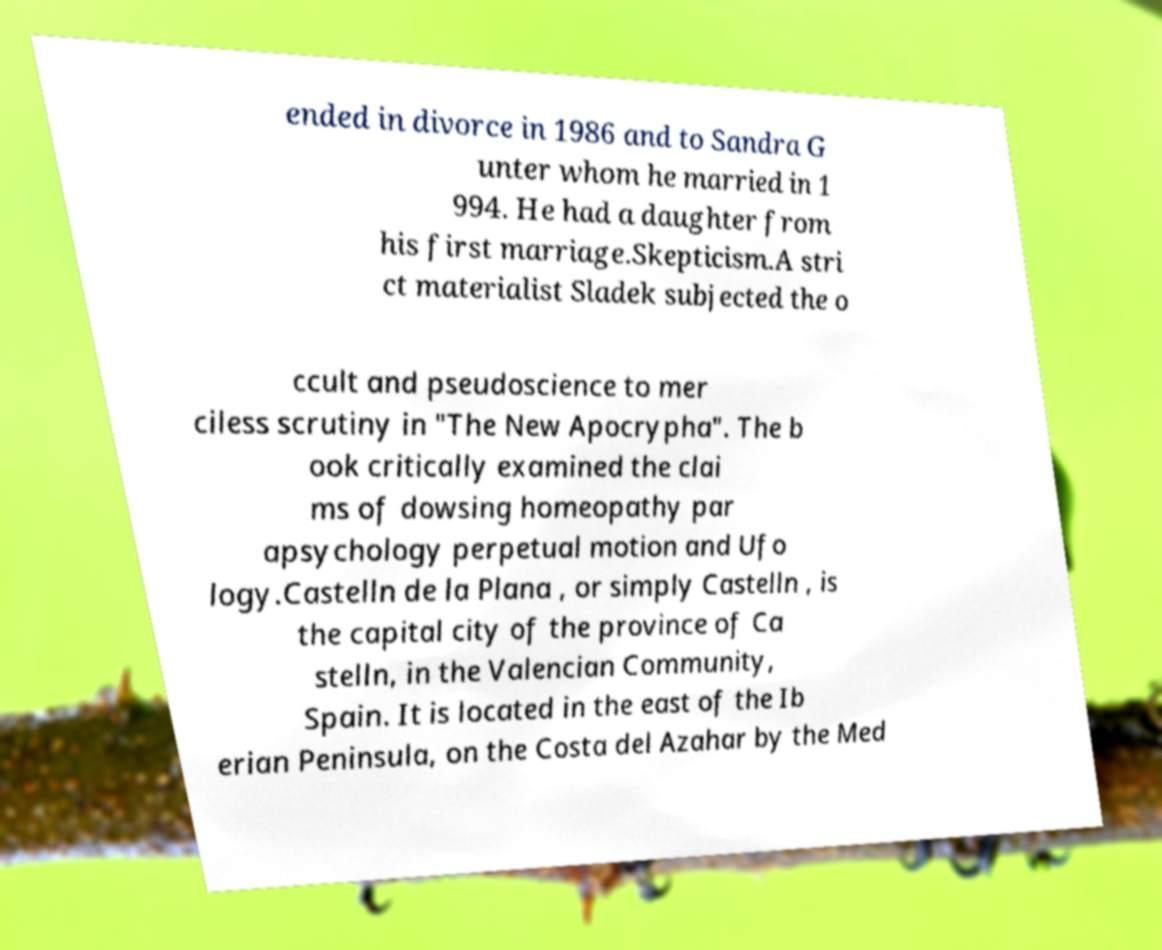Please read and relay the text visible in this image. What does it say? ended in divorce in 1986 and to Sandra G unter whom he married in 1 994. He had a daughter from his first marriage.Skepticism.A stri ct materialist Sladek subjected the o ccult and pseudoscience to mer ciless scrutiny in "The New Apocrypha". The b ook critically examined the clai ms of dowsing homeopathy par apsychology perpetual motion and Ufo logy.Castelln de la Plana , or simply Castelln , is the capital city of the province of Ca stelln, in the Valencian Community, Spain. It is located in the east of the Ib erian Peninsula, on the Costa del Azahar by the Med 